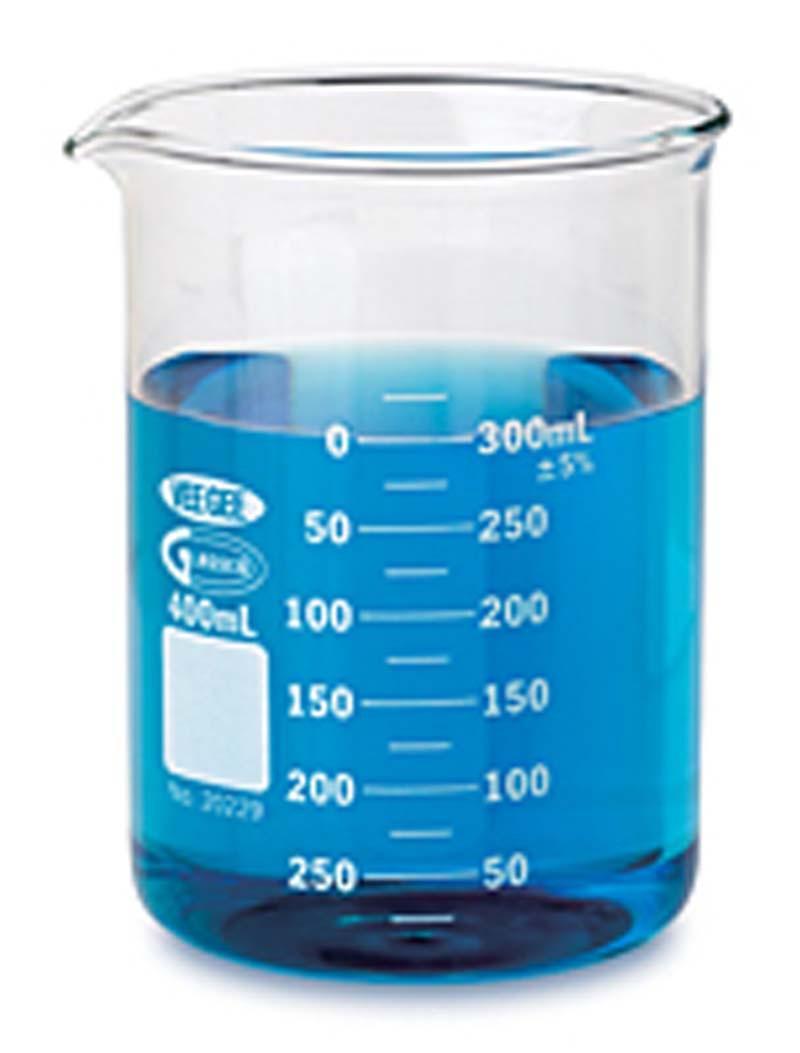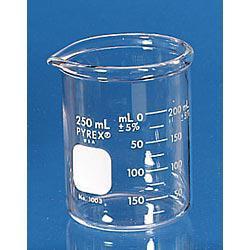The first image is the image on the left, the second image is the image on the right. Examine the images to the left and right. Is the description "There is exactly one empty beaker." accurate? Answer yes or no. Yes. The first image is the image on the left, the second image is the image on the right. Examine the images to the left and right. Is the description "The right image shows multiple beakers." accurate? Answer yes or no. No. 